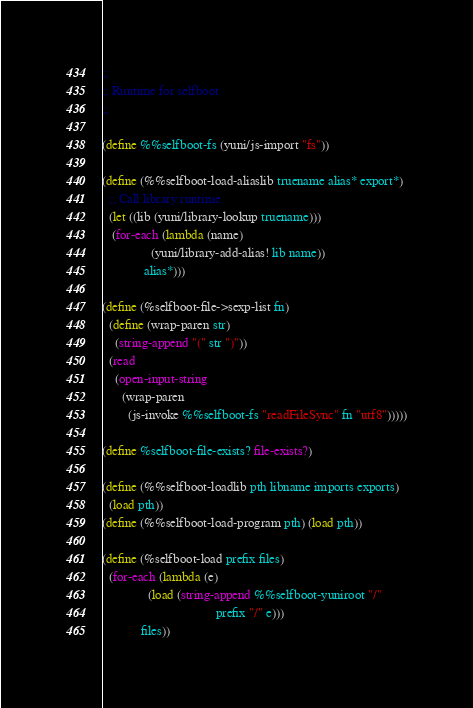Convert code to text. <code><loc_0><loc_0><loc_500><loc_500><_Scheme_>;;
;; Runtime for selfboot
;;

(define %%selfboot-fs (yuni/js-import "fs"))

(define (%%selfboot-load-aliaslib truename alias* export*)
  ;; Call library runtime
  (let ((lib (yuni/library-lookup truename)))
   (for-each (lambda (name)
               (yuni/library-add-alias! lib name))
             alias*)))

(define (%selfboot-file->sexp-list fn)
  (define (wrap-paren str)
    (string-append "(" str ")"))
  (read
    (open-input-string
      (wrap-paren
        (js-invoke %%selfboot-fs "readFileSync" fn "utf8")))))

(define %selfboot-file-exists? file-exists?)

(define (%%selfboot-loadlib pth libname imports exports)
  (load pth))
(define (%%selfboot-load-program pth) (load pth))

(define (%selfboot-load prefix files)
  (for-each (lambda (e)
              (load (string-append %%selfboot-yuniroot "/" 
                                   prefix "/" e)))
            files))

</code> 